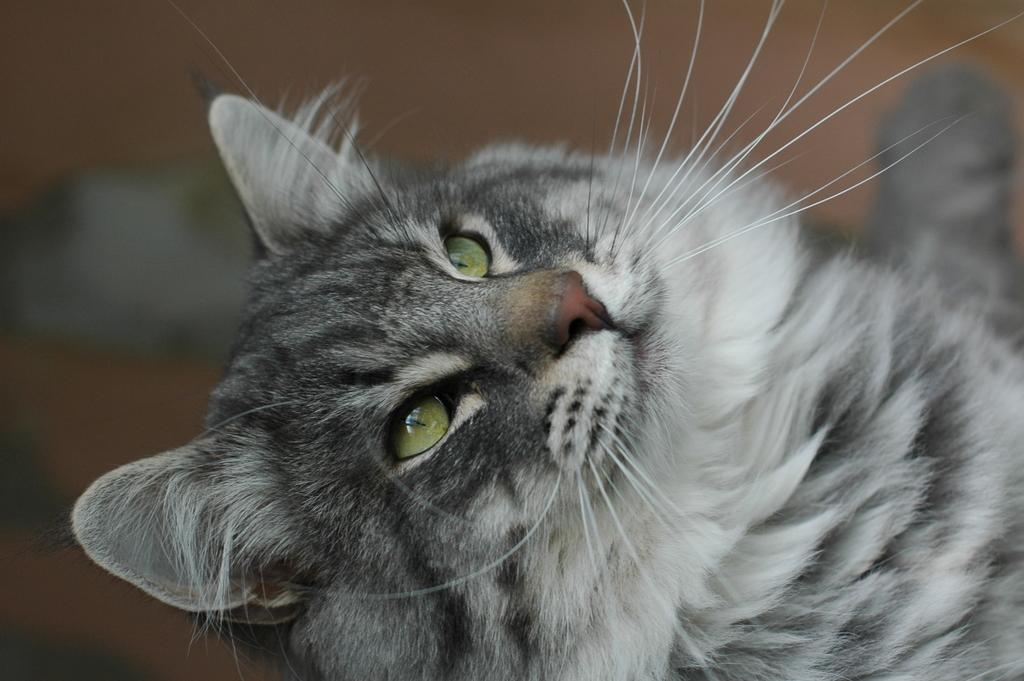What type of animal is in the image? There is a cat in the image. Can you describe the color pattern of the cat? The cat is gray and white in color. What can be observed about the background of the image? The background of the image is blurred. How many fingers can be seen on the cat's paw in the image? Cats do not have fingers like humans; they have claws, which are not visible in the image. 